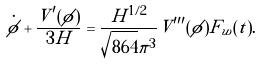Convert formula to latex. <formula><loc_0><loc_0><loc_500><loc_500>\dot { \phi } + \frac { V ^ { \prime } ( \phi ) } { 3 H } = \frac { H ^ { 1 / 2 } } { \sqrt { 8 6 4 } \pi ^ { 3 } } V ^ { \prime \prime \prime } ( \phi ) F _ { w } ( t ) .</formula> 